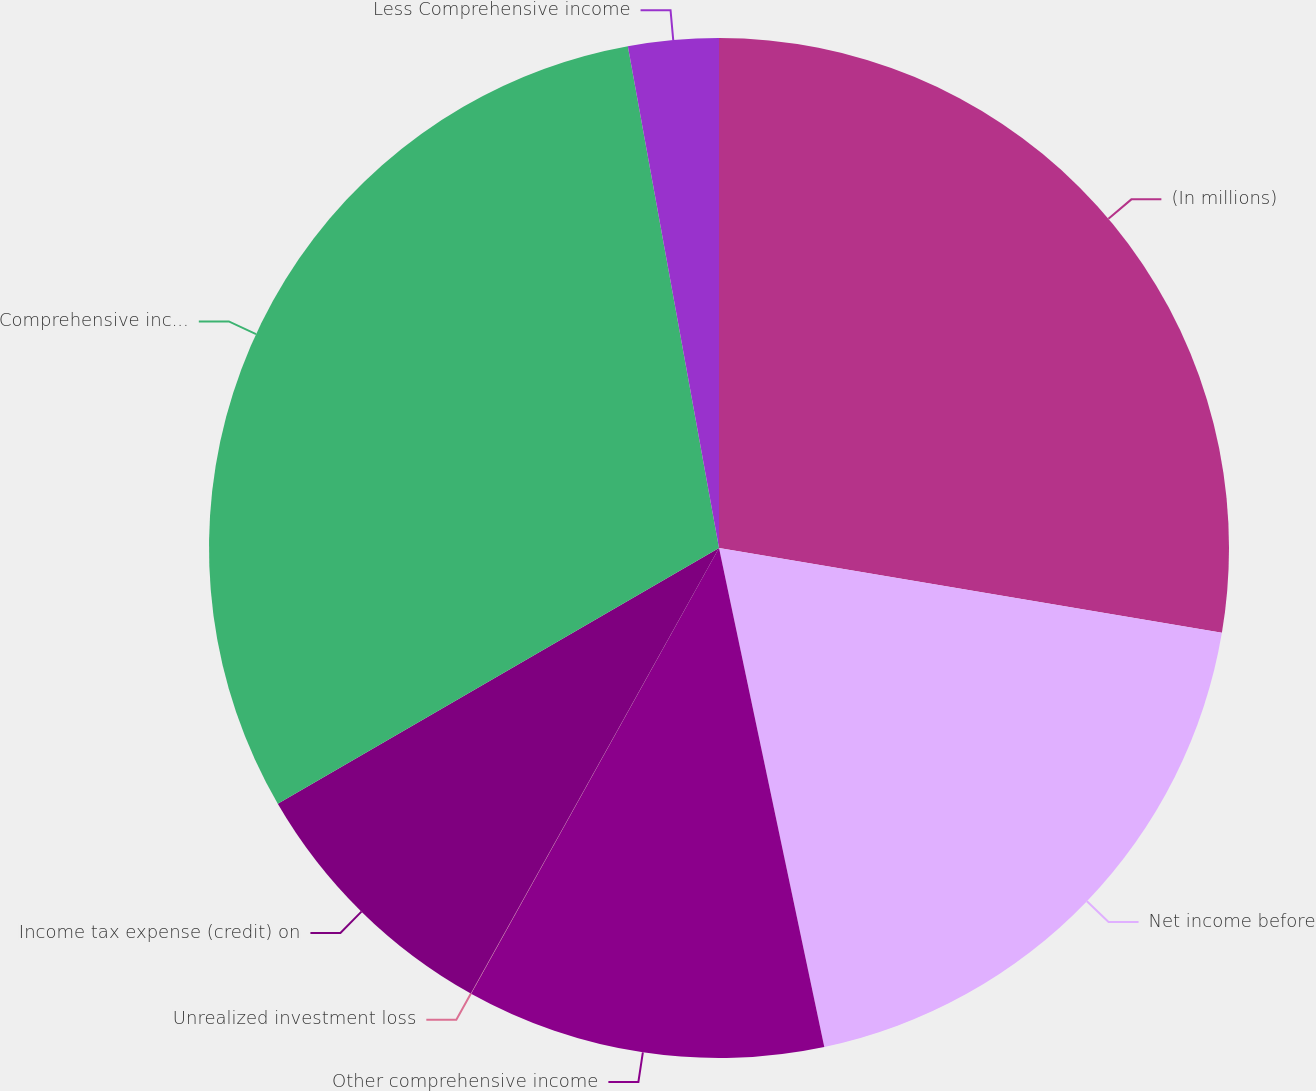Convert chart. <chart><loc_0><loc_0><loc_500><loc_500><pie_chart><fcel>(In millions)<fcel>Net income before<fcel>Other comprehensive income<fcel>Unrealized investment loss<fcel>Income tax expense (credit) on<fcel>Comprehensive income<fcel>Less Comprehensive income<nl><fcel>27.66%<fcel>19.03%<fcel>11.39%<fcel>0.01%<fcel>8.55%<fcel>30.5%<fcel>2.86%<nl></chart> 